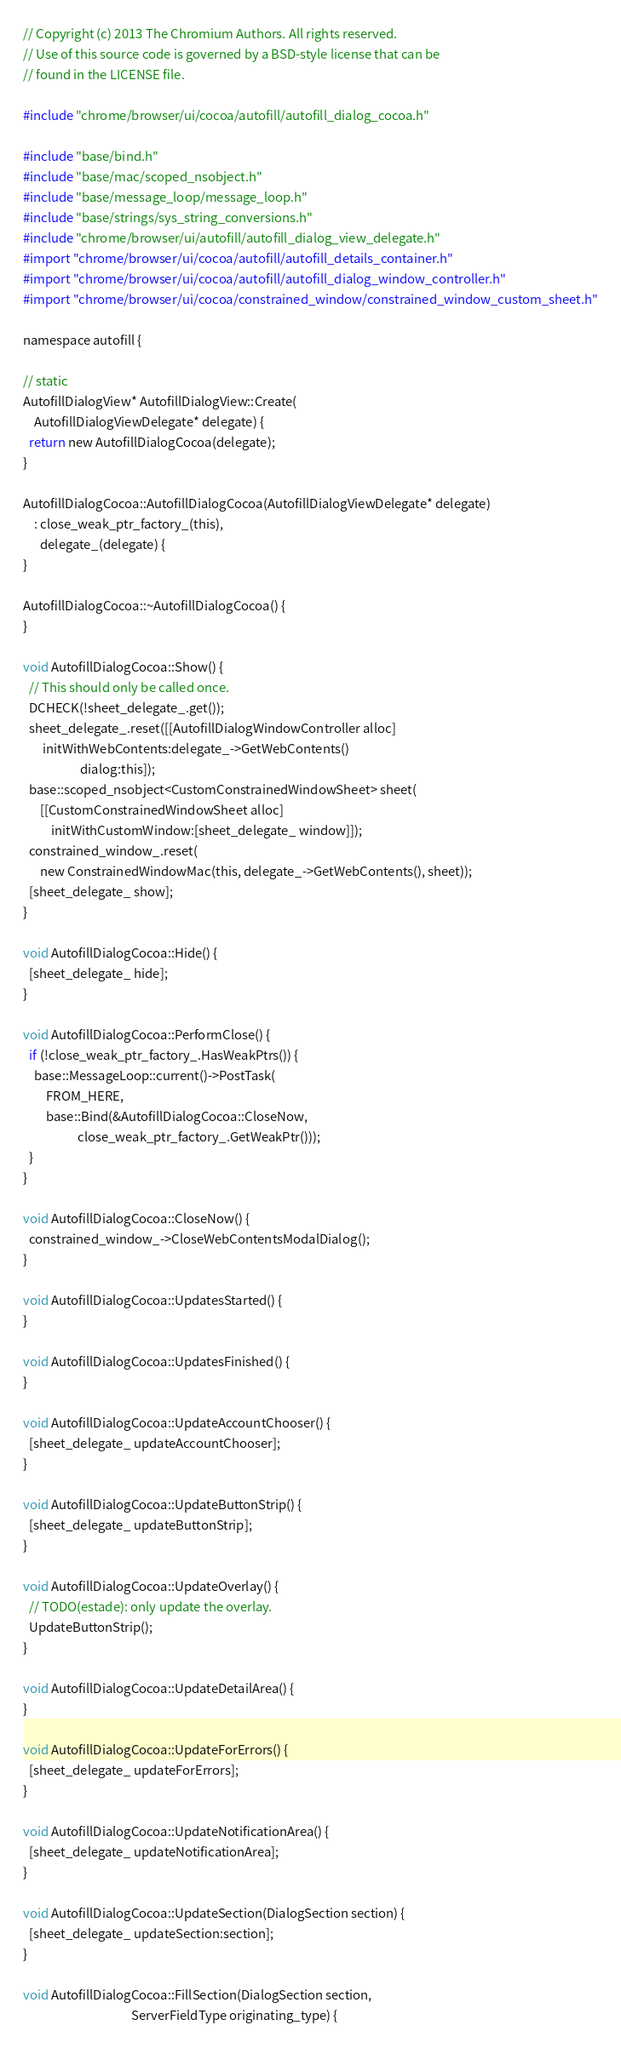Convert code to text. <code><loc_0><loc_0><loc_500><loc_500><_ObjectiveC_>// Copyright (c) 2013 The Chromium Authors. All rights reserved.
// Use of this source code is governed by a BSD-style license that can be
// found in the LICENSE file.

#include "chrome/browser/ui/cocoa/autofill/autofill_dialog_cocoa.h"

#include "base/bind.h"
#include "base/mac/scoped_nsobject.h"
#include "base/message_loop/message_loop.h"
#include "base/strings/sys_string_conversions.h"
#include "chrome/browser/ui/autofill/autofill_dialog_view_delegate.h"
#import "chrome/browser/ui/cocoa/autofill/autofill_details_container.h"
#import "chrome/browser/ui/cocoa/autofill/autofill_dialog_window_controller.h"
#import "chrome/browser/ui/cocoa/constrained_window/constrained_window_custom_sheet.h"

namespace autofill {

// static
AutofillDialogView* AutofillDialogView::Create(
    AutofillDialogViewDelegate* delegate) {
  return new AutofillDialogCocoa(delegate);
}

AutofillDialogCocoa::AutofillDialogCocoa(AutofillDialogViewDelegate* delegate)
    : close_weak_ptr_factory_(this),
      delegate_(delegate) {
}

AutofillDialogCocoa::~AutofillDialogCocoa() {
}

void AutofillDialogCocoa::Show() {
  // This should only be called once.
  DCHECK(!sheet_delegate_.get());
  sheet_delegate_.reset([[AutofillDialogWindowController alloc]
       initWithWebContents:delegate_->GetWebContents()
                    dialog:this]);
  base::scoped_nsobject<CustomConstrainedWindowSheet> sheet(
      [[CustomConstrainedWindowSheet alloc]
          initWithCustomWindow:[sheet_delegate_ window]]);
  constrained_window_.reset(
      new ConstrainedWindowMac(this, delegate_->GetWebContents(), sheet));
  [sheet_delegate_ show];
}

void AutofillDialogCocoa::Hide() {
  [sheet_delegate_ hide];
}

void AutofillDialogCocoa::PerformClose() {
  if (!close_weak_ptr_factory_.HasWeakPtrs()) {
    base::MessageLoop::current()->PostTask(
        FROM_HERE,
        base::Bind(&AutofillDialogCocoa::CloseNow,
                   close_weak_ptr_factory_.GetWeakPtr()));
  }
}

void AutofillDialogCocoa::CloseNow() {
  constrained_window_->CloseWebContentsModalDialog();
}

void AutofillDialogCocoa::UpdatesStarted() {
}

void AutofillDialogCocoa::UpdatesFinished() {
}

void AutofillDialogCocoa::UpdateAccountChooser() {
  [sheet_delegate_ updateAccountChooser];
}

void AutofillDialogCocoa::UpdateButtonStrip() {
  [sheet_delegate_ updateButtonStrip];
}

void AutofillDialogCocoa::UpdateOverlay() {
  // TODO(estade): only update the overlay.
  UpdateButtonStrip();
}

void AutofillDialogCocoa::UpdateDetailArea() {
}

void AutofillDialogCocoa::UpdateForErrors() {
  [sheet_delegate_ updateForErrors];
}

void AutofillDialogCocoa::UpdateNotificationArea() {
  [sheet_delegate_ updateNotificationArea];
}

void AutofillDialogCocoa::UpdateSection(DialogSection section) {
  [sheet_delegate_ updateSection:section];
}

void AutofillDialogCocoa::FillSection(DialogSection section,
                                      ServerFieldType originating_type) {</code> 